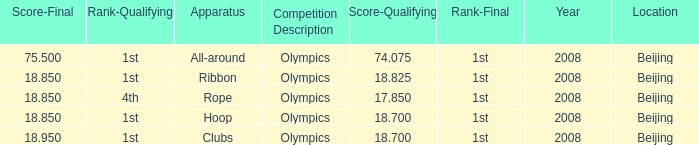What was her lowest ultimate score with a qualifying score of 7 75.5. 